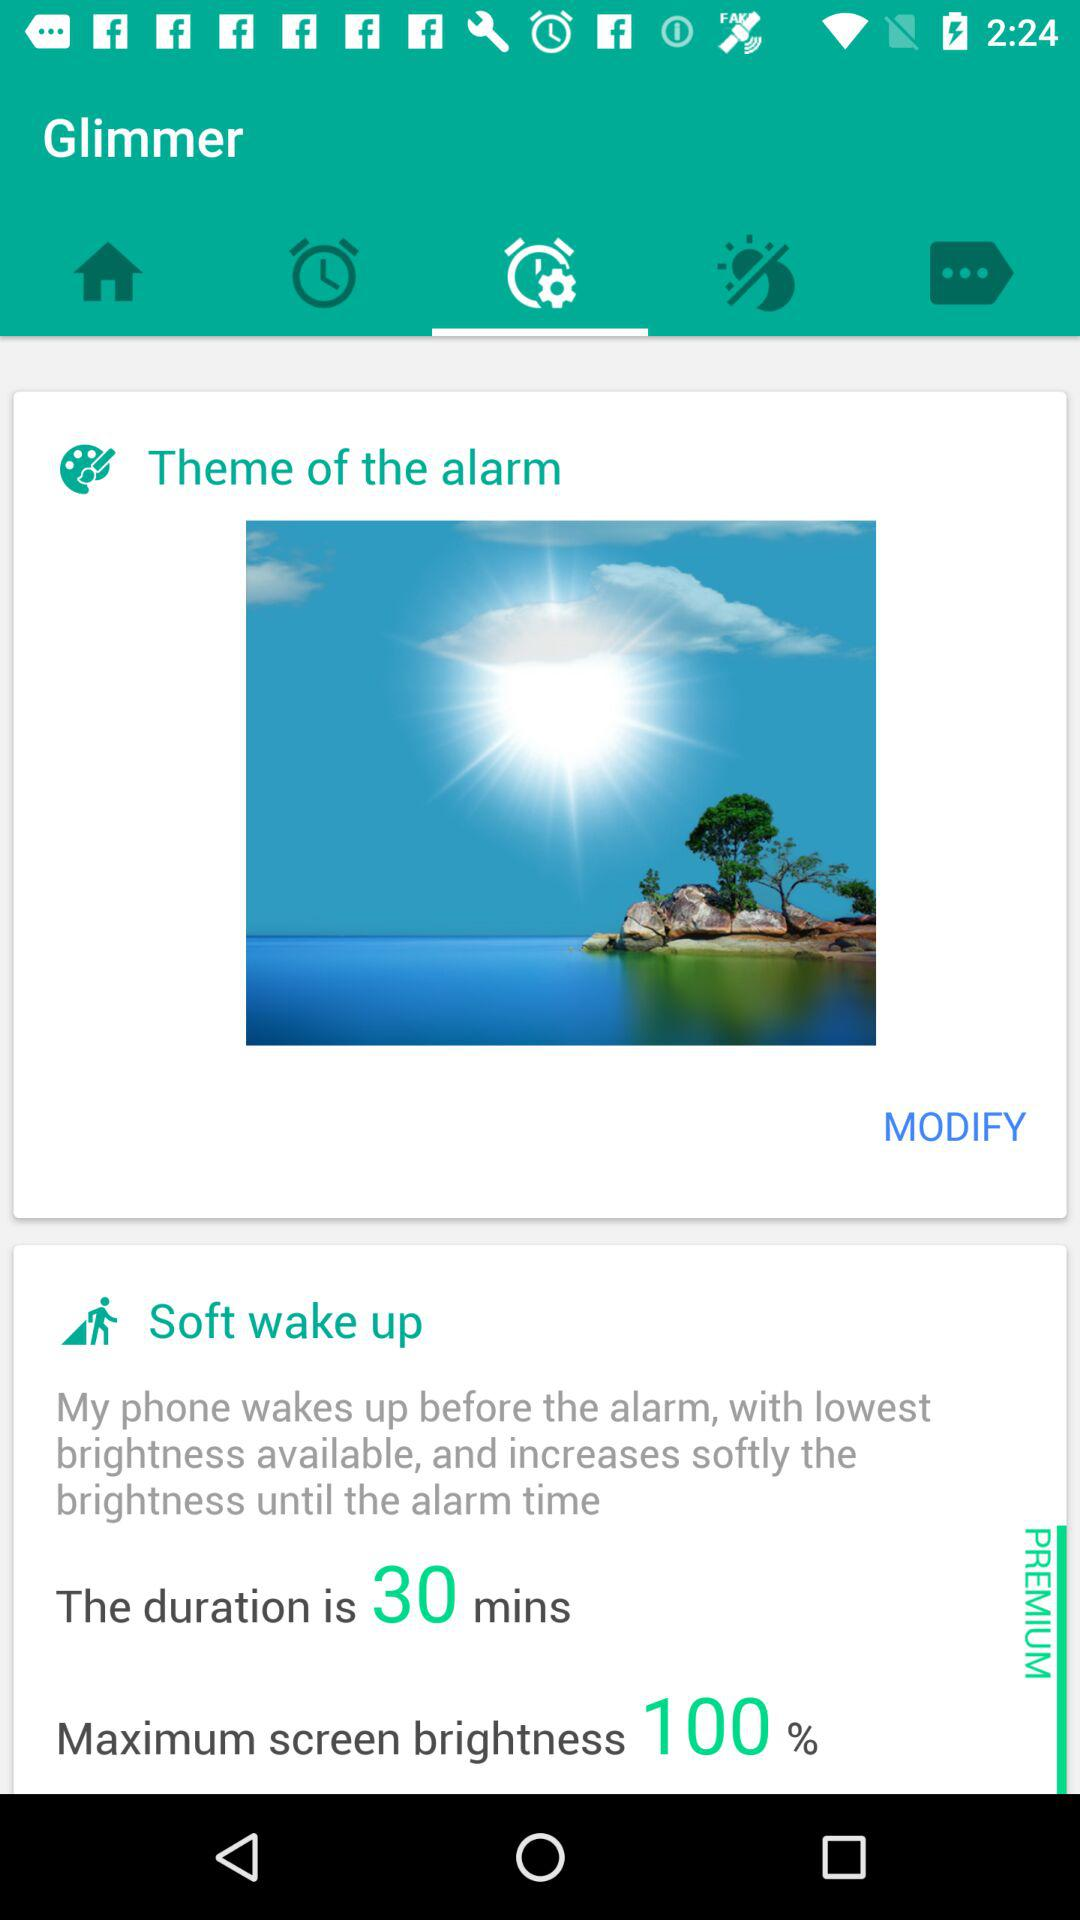How many minutes is the duration of the soft wake up?
Answer the question using a single word or phrase. 30 